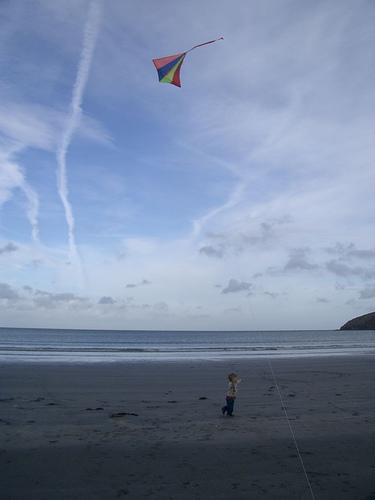Is the child stretching?
Be succinct. No. Three bikes are red, what color is other bike?
Short answer required. No bikes. What is in the sky?
Answer briefly. Kite. What color is the sky?
Short answer required. Blue. Are there waves?
Answer briefly. No. What is in the background?
Be succinct. Sky. What is the kite shaped to look like?
Write a very short answer. Triangle. Is the person flying this kite pictured in the photo?
Write a very short answer. Yes. Are there boats in the water?
Give a very brief answer. No. Are there any trademarked images in the photo?
Short answer required. No. What is the man carrying?
Short answer required. Kite. Are there clouds?
Write a very short answer. Yes. What is the object in the sky?
Concise answer only. Kite. Are there any people in the photo?
Quick response, please. Yes. How many people are visible?
Be succinct. 1. How many people walking on the beach?
Keep it brief. 1. Is this an island?
Give a very brief answer. No. 